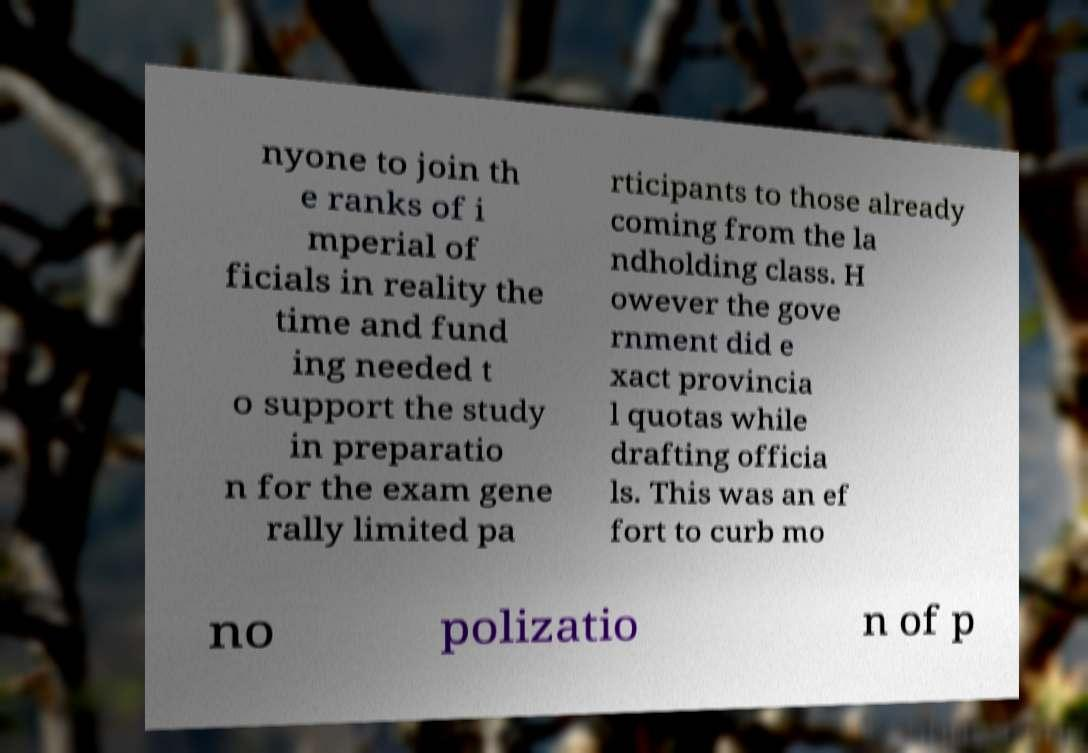Could you assist in decoding the text presented in this image and type it out clearly? nyone to join th e ranks of i mperial of ficials in reality the time and fund ing needed t o support the study in preparatio n for the exam gene rally limited pa rticipants to those already coming from the la ndholding class. H owever the gove rnment did e xact provincia l quotas while drafting officia ls. This was an ef fort to curb mo no polizatio n of p 